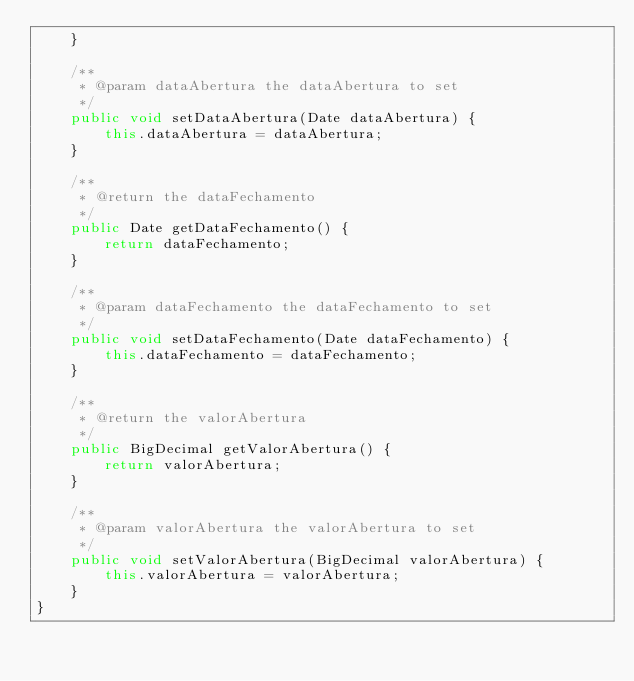<code> <loc_0><loc_0><loc_500><loc_500><_Java_>	}
	
	/**
	 * @param dataAbertura the dataAbertura to set
	 */
	public void setDataAbertura(Date dataAbertura) {
		this.dataAbertura = dataAbertura;
	}
	
	/**
	 * @return the dataFechamento
	 */
	public Date getDataFechamento() {
		return dataFechamento;
	}
	
	/**
	 * @param dataFechamento the dataFechamento to set
	 */
	public void setDataFechamento(Date dataFechamento) {
		this.dataFechamento = dataFechamento;
	}
	
	/**
	 * @return the valorAbertura
	 */
	public BigDecimal getValorAbertura() {
		return valorAbertura;
	}
	
	/**
	 * @param valorAbertura the valorAbertura to set
	 */
	public void setValorAbertura(BigDecimal valorAbertura) {
		this.valorAbertura = valorAbertura;
	}	
}</code> 